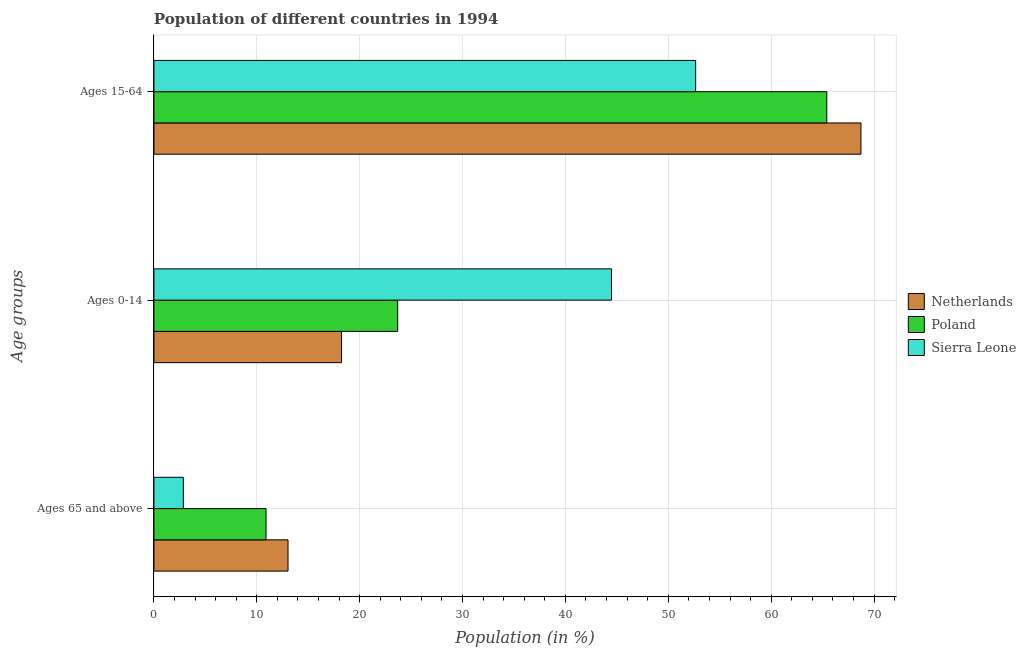How many different coloured bars are there?
Provide a short and direct response. 3. Are the number of bars on each tick of the Y-axis equal?
Your answer should be very brief. Yes. What is the label of the 3rd group of bars from the top?
Your answer should be very brief. Ages 65 and above. What is the percentage of population within the age-group of 65 and above in Netherlands?
Ensure brevity in your answer.  13.04. Across all countries, what is the maximum percentage of population within the age-group 15-64?
Your answer should be compact. 68.73. Across all countries, what is the minimum percentage of population within the age-group 15-64?
Your response must be concise. 52.66. In which country was the percentage of population within the age-group 0-14 maximum?
Ensure brevity in your answer.  Sierra Leone. What is the total percentage of population within the age-group of 65 and above in the graph?
Provide a short and direct response. 26.8. What is the difference between the percentage of population within the age-group of 65 and above in Sierra Leone and that in Poland?
Your response must be concise. -8.04. What is the difference between the percentage of population within the age-group of 65 and above in Sierra Leone and the percentage of population within the age-group 15-64 in Poland?
Give a very brief answer. -62.55. What is the average percentage of population within the age-group 15-64 per country?
Ensure brevity in your answer.  62.27. What is the difference between the percentage of population within the age-group 0-14 and percentage of population within the age-group 15-64 in Netherlands?
Provide a succinct answer. -50.49. In how many countries, is the percentage of population within the age-group 0-14 greater than 24 %?
Offer a very short reply. 1. What is the ratio of the percentage of population within the age-group of 65 and above in Poland to that in Sierra Leone?
Offer a terse response. 3.81. Is the difference between the percentage of population within the age-group 0-14 in Netherlands and Sierra Leone greater than the difference between the percentage of population within the age-group 15-64 in Netherlands and Sierra Leone?
Make the answer very short. No. What is the difference between the highest and the second highest percentage of population within the age-group 0-14?
Provide a succinct answer. 20.79. What is the difference between the highest and the lowest percentage of population within the age-group of 65 and above?
Ensure brevity in your answer.  10.17. In how many countries, is the percentage of population within the age-group of 65 and above greater than the average percentage of population within the age-group of 65 and above taken over all countries?
Offer a terse response. 2. What does the 3rd bar from the top in Ages 0-14 represents?
Provide a short and direct response. Netherlands. What does the 1st bar from the bottom in Ages 0-14 represents?
Give a very brief answer. Netherlands. Is it the case that in every country, the sum of the percentage of population within the age-group of 65 and above and percentage of population within the age-group 0-14 is greater than the percentage of population within the age-group 15-64?
Your response must be concise. No. How many countries are there in the graph?
Provide a succinct answer. 3. Are the values on the major ticks of X-axis written in scientific E-notation?
Offer a terse response. No. Does the graph contain any zero values?
Give a very brief answer. No. Where does the legend appear in the graph?
Your answer should be very brief. Center right. How many legend labels are there?
Your answer should be compact. 3. How are the legend labels stacked?
Offer a very short reply. Vertical. What is the title of the graph?
Offer a terse response. Population of different countries in 1994. What is the label or title of the Y-axis?
Provide a succinct answer. Age groups. What is the Population (in %) of Netherlands in Ages 65 and above?
Give a very brief answer. 13.04. What is the Population (in %) in Poland in Ages 65 and above?
Provide a succinct answer. 10.9. What is the Population (in %) of Sierra Leone in Ages 65 and above?
Make the answer very short. 2.86. What is the Population (in %) of Netherlands in Ages 0-14?
Offer a terse response. 18.24. What is the Population (in %) in Poland in Ages 0-14?
Your answer should be compact. 23.69. What is the Population (in %) of Sierra Leone in Ages 0-14?
Ensure brevity in your answer.  44.48. What is the Population (in %) of Netherlands in Ages 15-64?
Keep it short and to the point. 68.73. What is the Population (in %) of Poland in Ages 15-64?
Ensure brevity in your answer.  65.41. What is the Population (in %) in Sierra Leone in Ages 15-64?
Offer a terse response. 52.66. Across all Age groups, what is the maximum Population (in %) of Netherlands?
Provide a succinct answer. 68.73. Across all Age groups, what is the maximum Population (in %) of Poland?
Offer a very short reply. 65.41. Across all Age groups, what is the maximum Population (in %) in Sierra Leone?
Offer a very short reply. 52.66. Across all Age groups, what is the minimum Population (in %) in Netherlands?
Make the answer very short. 13.04. Across all Age groups, what is the minimum Population (in %) in Poland?
Provide a succinct answer. 10.9. Across all Age groups, what is the minimum Population (in %) in Sierra Leone?
Provide a short and direct response. 2.86. What is the total Population (in %) in Netherlands in the graph?
Provide a short and direct response. 100. What is the difference between the Population (in %) in Netherlands in Ages 65 and above and that in Ages 0-14?
Keep it short and to the point. -5.2. What is the difference between the Population (in %) in Poland in Ages 65 and above and that in Ages 0-14?
Ensure brevity in your answer.  -12.79. What is the difference between the Population (in %) of Sierra Leone in Ages 65 and above and that in Ages 0-14?
Provide a short and direct response. -41.62. What is the difference between the Population (in %) in Netherlands in Ages 65 and above and that in Ages 15-64?
Offer a very short reply. -55.69. What is the difference between the Population (in %) in Poland in Ages 65 and above and that in Ages 15-64?
Your answer should be very brief. -54.51. What is the difference between the Population (in %) of Sierra Leone in Ages 65 and above and that in Ages 15-64?
Your answer should be compact. -49.8. What is the difference between the Population (in %) in Netherlands in Ages 0-14 and that in Ages 15-64?
Offer a terse response. -50.49. What is the difference between the Population (in %) in Poland in Ages 0-14 and that in Ages 15-64?
Ensure brevity in your answer.  -41.71. What is the difference between the Population (in %) in Sierra Leone in Ages 0-14 and that in Ages 15-64?
Offer a very short reply. -8.18. What is the difference between the Population (in %) in Netherlands in Ages 65 and above and the Population (in %) in Poland in Ages 0-14?
Provide a short and direct response. -10.66. What is the difference between the Population (in %) in Netherlands in Ages 65 and above and the Population (in %) in Sierra Leone in Ages 0-14?
Your response must be concise. -31.44. What is the difference between the Population (in %) of Poland in Ages 65 and above and the Population (in %) of Sierra Leone in Ages 0-14?
Provide a short and direct response. -33.58. What is the difference between the Population (in %) in Netherlands in Ages 65 and above and the Population (in %) in Poland in Ages 15-64?
Provide a succinct answer. -52.37. What is the difference between the Population (in %) of Netherlands in Ages 65 and above and the Population (in %) of Sierra Leone in Ages 15-64?
Your answer should be very brief. -39.62. What is the difference between the Population (in %) of Poland in Ages 65 and above and the Population (in %) of Sierra Leone in Ages 15-64?
Your answer should be compact. -41.76. What is the difference between the Population (in %) in Netherlands in Ages 0-14 and the Population (in %) in Poland in Ages 15-64?
Offer a terse response. -47.17. What is the difference between the Population (in %) in Netherlands in Ages 0-14 and the Population (in %) in Sierra Leone in Ages 15-64?
Keep it short and to the point. -34.42. What is the difference between the Population (in %) of Poland in Ages 0-14 and the Population (in %) of Sierra Leone in Ages 15-64?
Make the answer very short. -28.97. What is the average Population (in %) of Netherlands per Age groups?
Ensure brevity in your answer.  33.33. What is the average Population (in %) in Poland per Age groups?
Ensure brevity in your answer.  33.33. What is the average Population (in %) in Sierra Leone per Age groups?
Provide a short and direct response. 33.33. What is the difference between the Population (in %) of Netherlands and Population (in %) of Poland in Ages 65 and above?
Your answer should be very brief. 2.14. What is the difference between the Population (in %) of Netherlands and Population (in %) of Sierra Leone in Ages 65 and above?
Give a very brief answer. 10.17. What is the difference between the Population (in %) of Poland and Population (in %) of Sierra Leone in Ages 65 and above?
Give a very brief answer. 8.04. What is the difference between the Population (in %) in Netherlands and Population (in %) in Poland in Ages 0-14?
Your answer should be very brief. -5.46. What is the difference between the Population (in %) in Netherlands and Population (in %) in Sierra Leone in Ages 0-14?
Your answer should be very brief. -26.24. What is the difference between the Population (in %) in Poland and Population (in %) in Sierra Leone in Ages 0-14?
Offer a very short reply. -20.79. What is the difference between the Population (in %) in Netherlands and Population (in %) in Poland in Ages 15-64?
Give a very brief answer. 3.32. What is the difference between the Population (in %) of Netherlands and Population (in %) of Sierra Leone in Ages 15-64?
Provide a short and direct response. 16.07. What is the difference between the Population (in %) of Poland and Population (in %) of Sierra Leone in Ages 15-64?
Ensure brevity in your answer.  12.75. What is the ratio of the Population (in %) in Netherlands in Ages 65 and above to that in Ages 0-14?
Provide a short and direct response. 0.71. What is the ratio of the Population (in %) in Poland in Ages 65 and above to that in Ages 0-14?
Your response must be concise. 0.46. What is the ratio of the Population (in %) of Sierra Leone in Ages 65 and above to that in Ages 0-14?
Your response must be concise. 0.06. What is the ratio of the Population (in %) in Netherlands in Ages 65 and above to that in Ages 15-64?
Your answer should be compact. 0.19. What is the ratio of the Population (in %) of Poland in Ages 65 and above to that in Ages 15-64?
Ensure brevity in your answer.  0.17. What is the ratio of the Population (in %) in Sierra Leone in Ages 65 and above to that in Ages 15-64?
Offer a very short reply. 0.05. What is the ratio of the Population (in %) of Netherlands in Ages 0-14 to that in Ages 15-64?
Your response must be concise. 0.27. What is the ratio of the Population (in %) of Poland in Ages 0-14 to that in Ages 15-64?
Make the answer very short. 0.36. What is the ratio of the Population (in %) in Sierra Leone in Ages 0-14 to that in Ages 15-64?
Your response must be concise. 0.84. What is the difference between the highest and the second highest Population (in %) of Netherlands?
Make the answer very short. 50.49. What is the difference between the highest and the second highest Population (in %) of Poland?
Offer a terse response. 41.71. What is the difference between the highest and the second highest Population (in %) of Sierra Leone?
Keep it short and to the point. 8.18. What is the difference between the highest and the lowest Population (in %) of Netherlands?
Offer a terse response. 55.69. What is the difference between the highest and the lowest Population (in %) of Poland?
Offer a very short reply. 54.51. What is the difference between the highest and the lowest Population (in %) of Sierra Leone?
Offer a very short reply. 49.8. 